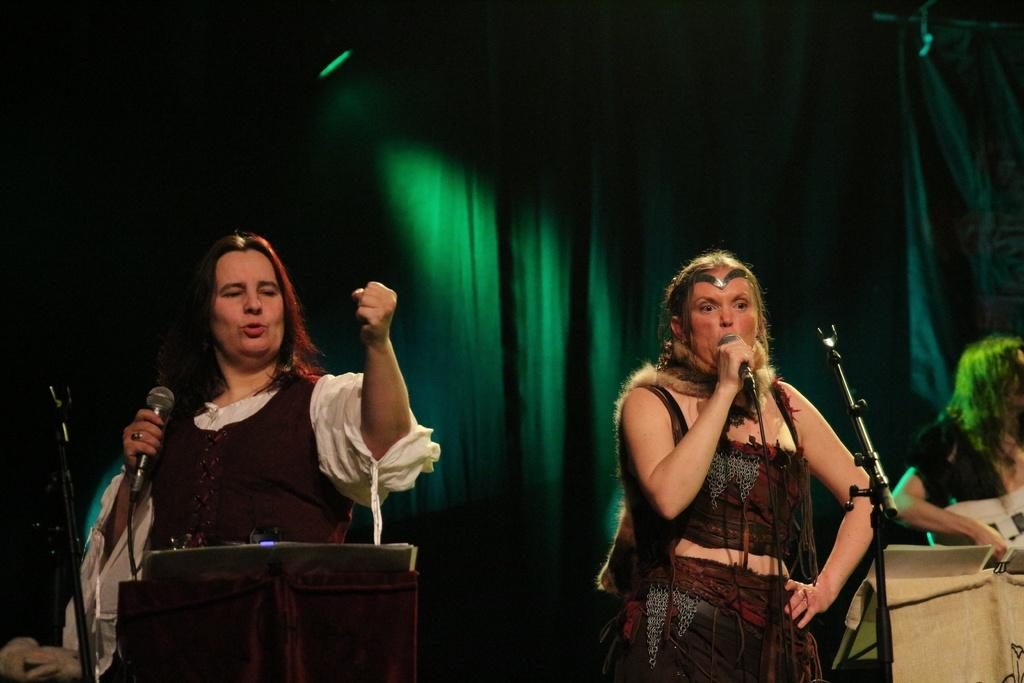What type of people can be seen in the image? There are women in the image. What are some of the women doing in the image? Some of the women are standing, and some of them are holding microphones. What are the women wearing in the image? The women are wearing costumes. Where is the sofa located in the image? There is no sofa present in the image. What is the relation between the women in the image? The provided facts do not give information about the relationship between the women. 